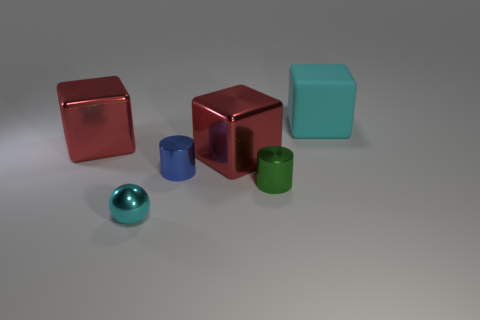Is there a rubber block that has the same color as the tiny sphere?
Offer a very short reply. Yes. What is the material of the object that is the same color as the matte cube?
Give a very brief answer. Metal. What size is the shiny thing that is the same color as the matte cube?
Offer a terse response. Small. Is there any other thing that has the same material as the big cyan thing?
Your answer should be very brief. No. Are there more big brown metallic cylinders than large matte things?
Keep it short and to the point. No. What is the shape of the cyan object in front of the cyan object on the right side of the cylinder that is to the right of the small blue metallic object?
Your answer should be very brief. Sphere. Is the material of the large red thing on the right side of the tiny metal ball the same as the cyan object to the right of the tiny cyan thing?
Make the answer very short. No. What is the shape of the small blue thing that is made of the same material as the green cylinder?
Provide a succinct answer. Cylinder. What number of rubber things are there?
Ensure brevity in your answer.  1. What material is the cyan object behind the cyan thing to the left of the green metal cylinder?
Offer a very short reply. Rubber. 